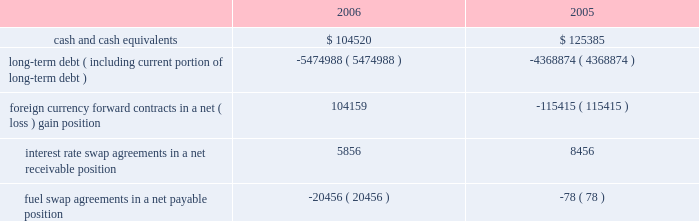Note 9 .
Retirement plan we maintain a defined contribution pension plan covering full-time shoreside employees who have completed the minimum period of continuous service .
Annual contributions to the plan are based on fixed percentages of participants 2019 salaries and years of service , not to exceed certain maximums .
Pension cost was $ 13.9 million , $ 12.8 million and $ 12.2 million for the years ended december 31 , 2006 , 2005 and 2004 , respectively .
Note 10 .
Income taxes we and the majority of our subsidiaries are currently exempt from united states corporate tax on income from the international opera- tion of ships pursuant to section 883 of the internal revenue code .
Income tax expense related to our remaining subsidiaries was not significant for the years ended december 31 , 2006 , 2005 and 2004 .
Final regulations under section 883 were published on august 26 , 2003 , and were effective for the year ended december 31 , 2005 .
These regulations confirmed that we qualify for the exemption provid- ed by section 883 , but also narrowed the scope of activities which are considered by the internal revenue service to be incidental to the international operation of ships .
The activities listed in the regula- tions as not being incidental to the international operation of ships include income from the sale of air and other transportation such as transfers , shore excursions and pre and post cruise tours .
To the extent the income from such activities is earned from sources within the united states , such income will be subject to united states taxa- tion .
The application of these new regulations reduced our net income for the years ended december 31 , 2006 and december 31 , 2005 by approximately $ 6.3 million and $ 14.0 million , respectively .
Note 11 .
Financial instruments the estimated fair values of our financial instruments are as follows ( in thousands ) : .
Long-term debt ( including current portion of long-term debt ) ( 5474988 ) ( 4368874 ) foreign currency forward contracts in a net ( loss ) gain position 104159 ( 115415 ) interest rate swap agreements in a net receivable position 5856 8456 fuel swap agreements in a net payable position ( 20456 ) ( 78 ) the reported fair values are based on a variety of factors and assumptions .
Accordingly , the fair values may not represent actual values of the financial instruments that could have been realized as of december 31 , 2006 or 2005 , or that will be realized in the future and do not include expenses that could be incurred in an actual sale or settlement .
Our financial instruments are not held for trading or speculative purposes .
Our exposure under foreign currency contracts , interest rate and fuel swap agreements is limited to the cost of replacing the contracts in the event of non-performance by the counterparties to the contracts , all of which are currently our lending banks .
To minimize this risk , we select counterparties with credit risks acceptable to us and we limit our exposure to an individual counterparty .
Furthermore , all foreign currency forward contracts are denominated in primary currencies .
Cash and cash equivalents the carrying amounts of cash and cash equivalents approximate their fair values due to the short maturity of these instruments .
Long-term debt the fair values of our senior notes and senior debentures were esti- mated by obtaining quoted market prices .
The fair values of all other debt were estimated using discounted cash flow analyses based on market rates available to us for similar debt with the same remaining maturities .
Foreign currency contracts the fair values of our foreign currency forward contracts were esti- mated using current market prices for similar instruments .
Our expo- sure to market risk for fluctuations in foreign currency exchange rates relates to six ship construction contracts and forecasted transactions .
We use foreign currency forward contracts to mitigate the impact of fluctuations in foreign currency exchange rates .
As of december 31 , 2006 , we had foreign currency forward contracts in a notional amount of $ 3.8 billion maturing through 2009 .
As of december 31 , 2006 , the fair value of our foreign currency forward contracts related to the six ship construction contracts , which are designated as fair value hedges , was a net unrealized gain of approximately $ 106.3 mil- lion .
At december 31 , 2005 , the fair value of our foreign currency for- ward contracts related to three ship construction contracts , designated as fair value hedges , was a net unrealized loss of approx- imately $ 103.4 million .
The fair value of our foreign currency forward contracts related to the other ship construction contract at december 31 , 2005 , which was designated as a cash flow hedge , was an unre- alized loss , of approximately $ 7.8 million .
At december 31 , 2006 , approximately 11% ( 11 % ) of the aggregate cost of the ships was exposed to fluctuations in the euro exchange rate .
R o y a l c a r i b b e a n c r u i s e s l t d .
3 5 notes to the consolidated financial statements ( continued ) 51392_financials-v9.qxp 6/7/07 3:40 pm page 35 .
What was the percentage increase in the cash and cash equivalents from 2005 to 2006? 
Computations: ((104520 - 125385) / 125385)
Answer: -0.16641. 